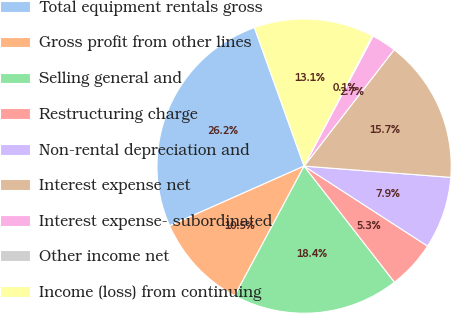Convert chart to OTSL. <chart><loc_0><loc_0><loc_500><loc_500><pie_chart><fcel>Total equipment rentals gross<fcel>Gross profit from other lines<fcel>Selling general and<fcel>Restructuring charge<fcel>Non-rental depreciation and<fcel>Interest expense net<fcel>Interest expense- subordinated<fcel>Other income net<fcel>Income (loss) from continuing<nl><fcel>26.17%<fcel>10.53%<fcel>18.35%<fcel>5.32%<fcel>7.93%<fcel>15.74%<fcel>2.71%<fcel>0.11%<fcel>13.14%<nl></chart> 